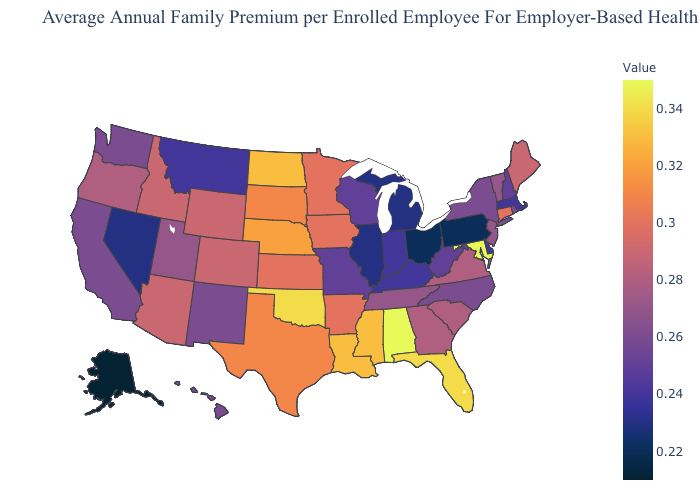Does Nevada have the lowest value in the USA?
Keep it brief. No. Which states hav the highest value in the Northeast?
Short answer required. Connecticut. Among the states that border South Carolina , does Georgia have the highest value?
Short answer required. Yes. 